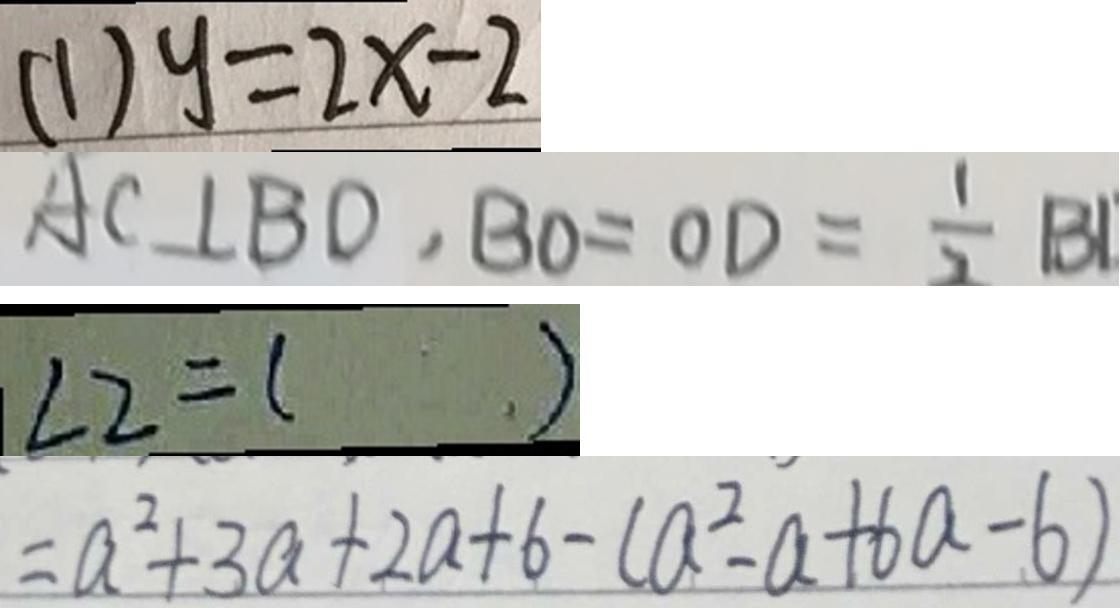Convert formula to latex. <formula><loc_0><loc_0><loc_500><loc_500>( 1 ) y = 2 x - 2 
 A C \bot B D , B O = O D = \frac { 1 } { 2 } B 1 
 \angle 2 = ( ) 
 = a ^ { 2 } + 3 a + 2 a + 6 - ( a ^ { 2 } - a + 6 a - b )</formula> 